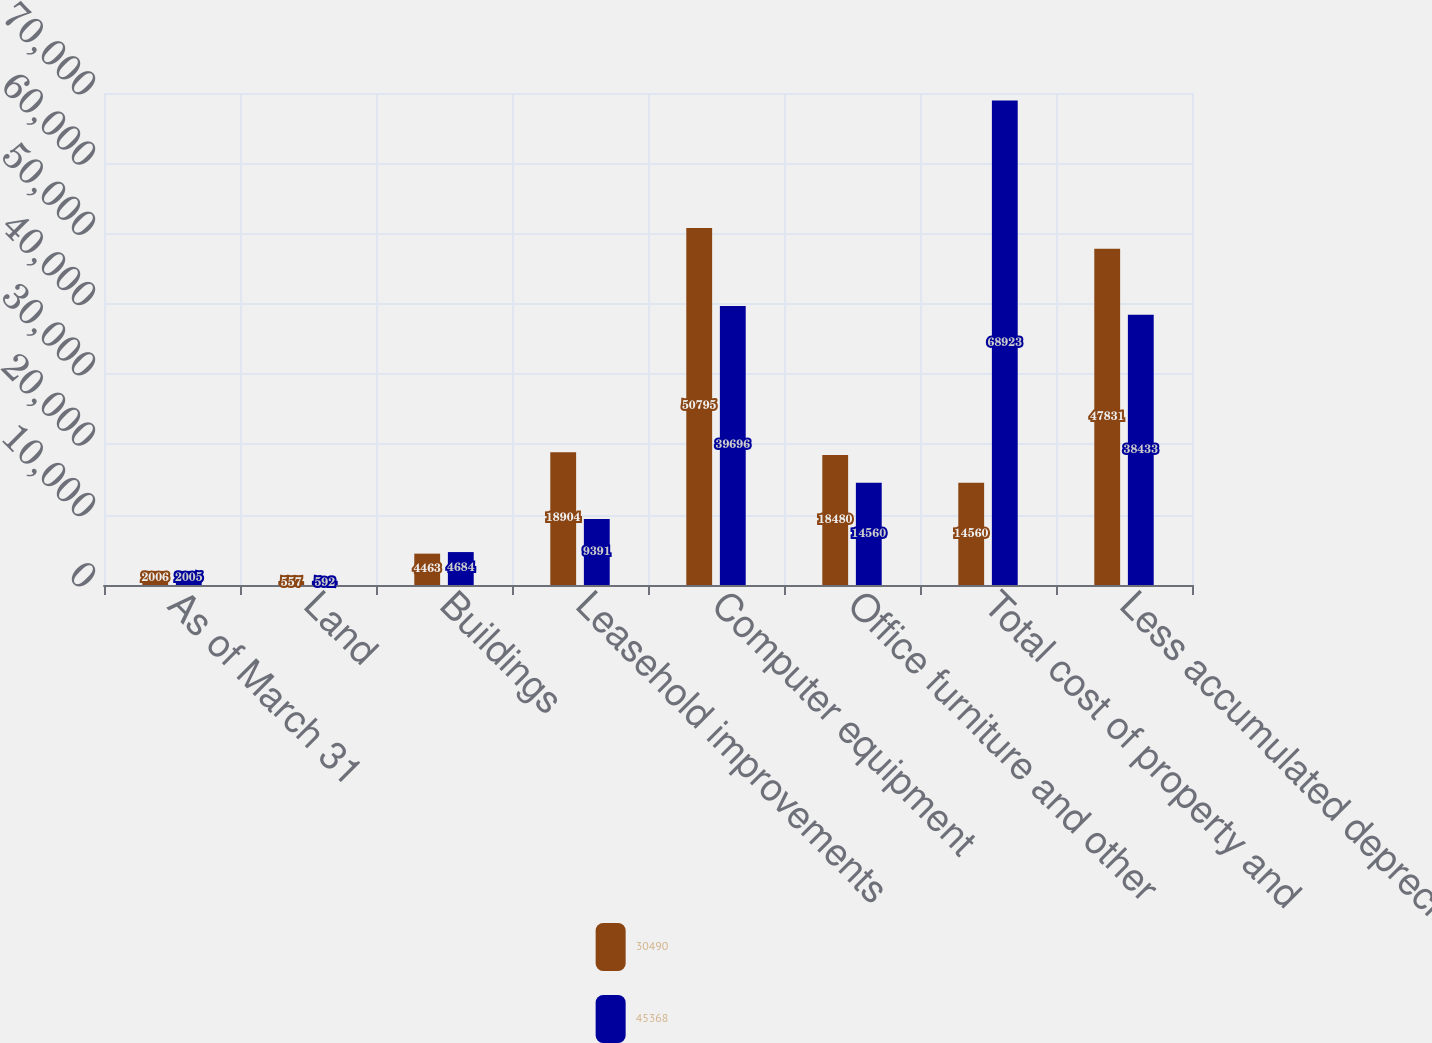Convert chart. <chart><loc_0><loc_0><loc_500><loc_500><stacked_bar_chart><ecel><fcel>As of March 31<fcel>Land<fcel>Buildings<fcel>Leasehold improvements<fcel>Computer equipment<fcel>Office furniture and other<fcel>Total cost of property and<fcel>Less accumulated depreciation<nl><fcel>30490<fcel>2006<fcel>557<fcel>4463<fcel>18904<fcel>50795<fcel>18480<fcel>14560<fcel>47831<nl><fcel>45368<fcel>2005<fcel>592<fcel>4684<fcel>9391<fcel>39696<fcel>14560<fcel>68923<fcel>38433<nl></chart> 